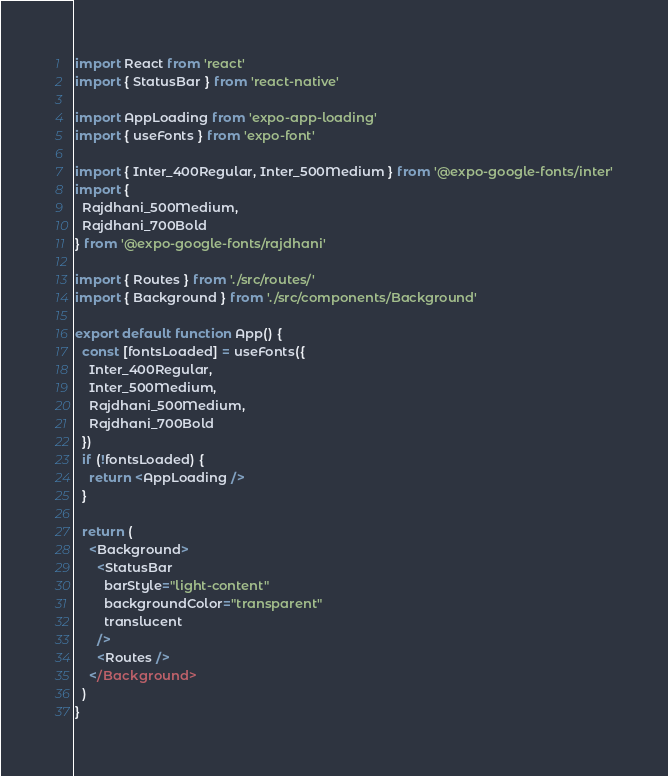Convert code to text. <code><loc_0><loc_0><loc_500><loc_500><_TypeScript_>import React from 'react'
import { StatusBar } from 'react-native'

import AppLoading from 'expo-app-loading'
import { useFonts } from 'expo-font'

import { Inter_400Regular, Inter_500Medium } from '@expo-google-fonts/inter'
import {
  Rajdhani_500Medium,
  Rajdhani_700Bold
} from '@expo-google-fonts/rajdhani'

import { Routes } from './src/routes/'
import { Background } from './src/components/Background'

export default function App() {
  const [fontsLoaded] = useFonts({
    Inter_400Regular,
    Inter_500Medium,
    Rajdhani_500Medium,
    Rajdhani_700Bold
  })
  if (!fontsLoaded) {
    return <AppLoading />
  }

  return (
    <Background>
      <StatusBar
        barStyle="light-content"
        backgroundColor="transparent"
        translucent
      />
      <Routes />
    </Background>
  )
}
</code> 